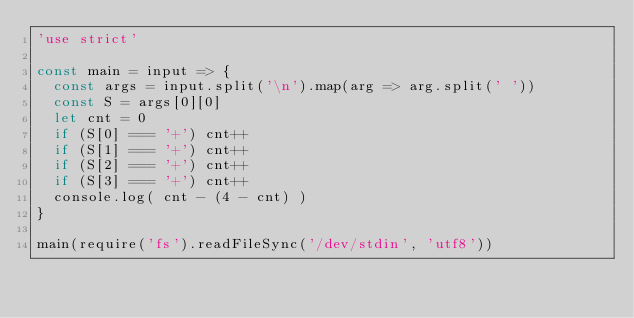Convert code to text. <code><loc_0><loc_0><loc_500><loc_500><_JavaScript_>'use strict'

const main = input => {
	const args = input.split('\n').map(arg => arg.split(' '))
	const S = args[0][0]
	let cnt = 0
	if (S[0] === '+') cnt++
	if (S[1] === '+') cnt++
	if (S[2] === '+') cnt++
	if (S[3] === '+') cnt++
	console.log( cnt - (4 - cnt) )
}

main(require('fs').readFileSync('/dev/stdin', 'utf8'))
</code> 